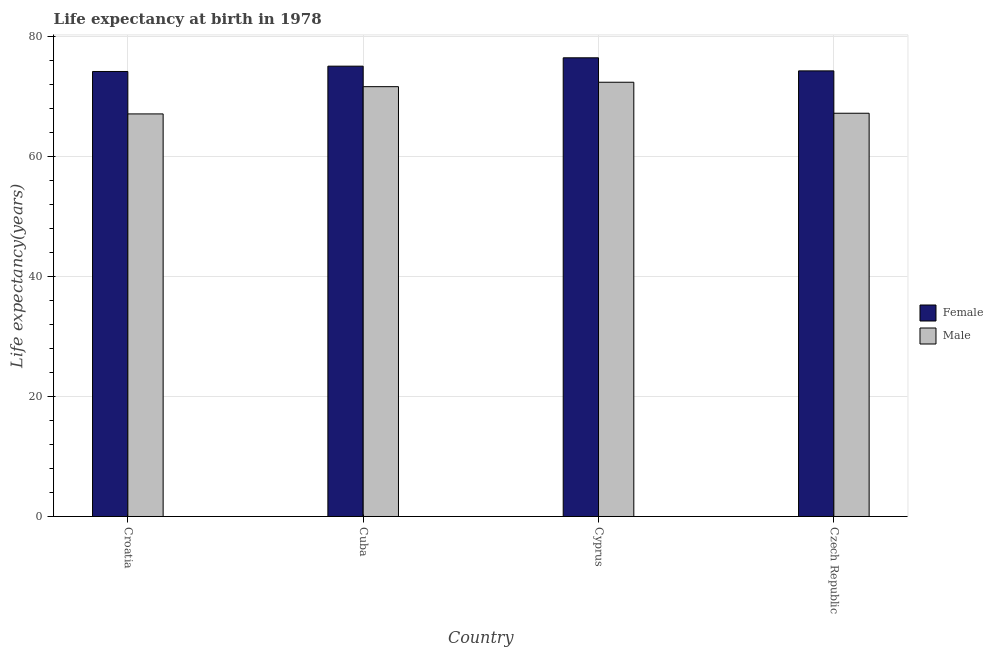Are the number of bars on each tick of the X-axis equal?
Offer a terse response. Yes. How many bars are there on the 1st tick from the left?
Your answer should be very brief. 2. How many bars are there on the 4th tick from the right?
Your answer should be compact. 2. What is the label of the 1st group of bars from the left?
Provide a short and direct response. Croatia. What is the life expectancy(male) in Croatia?
Your response must be concise. 67.09. Across all countries, what is the maximum life expectancy(male)?
Give a very brief answer. 72.37. Across all countries, what is the minimum life expectancy(male)?
Ensure brevity in your answer.  67.09. In which country was the life expectancy(female) maximum?
Keep it short and to the point. Cyprus. In which country was the life expectancy(male) minimum?
Provide a short and direct response. Croatia. What is the total life expectancy(female) in the graph?
Your response must be concise. 299.91. What is the difference between the life expectancy(female) in Croatia and that in Cuba?
Your response must be concise. -0.89. What is the difference between the life expectancy(female) in Croatia and the life expectancy(male) in Czech Republic?
Your answer should be very brief. 6.96. What is the average life expectancy(female) per country?
Your answer should be very brief. 74.98. What is the difference between the life expectancy(female) and life expectancy(male) in Cyprus?
Your answer should be compact. 4.07. What is the ratio of the life expectancy(female) in Cyprus to that in Czech Republic?
Your response must be concise. 1.03. Is the life expectancy(male) in Croatia less than that in Czech Republic?
Keep it short and to the point. Yes. Is the difference between the life expectancy(female) in Croatia and Cuba greater than the difference between the life expectancy(male) in Croatia and Cuba?
Provide a short and direct response. Yes. What is the difference between the highest and the second highest life expectancy(female)?
Make the answer very short. 1.39. What is the difference between the highest and the lowest life expectancy(female)?
Your response must be concise. 2.28. In how many countries, is the life expectancy(female) greater than the average life expectancy(female) taken over all countries?
Give a very brief answer. 2. What does the 2nd bar from the left in Cuba represents?
Make the answer very short. Male. How many countries are there in the graph?
Ensure brevity in your answer.  4. What is the difference between two consecutive major ticks on the Y-axis?
Offer a terse response. 20. Are the values on the major ticks of Y-axis written in scientific E-notation?
Your answer should be very brief. No. Does the graph contain any zero values?
Your answer should be compact. No. Where does the legend appear in the graph?
Provide a succinct answer. Center right. What is the title of the graph?
Provide a succinct answer. Life expectancy at birth in 1978. What is the label or title of the Y-axis?
Give a very brief answer. Life expectancy(years). What is the Life expectancy(years) of Female in Croatia?
Your answer should be compact. 74.16. What is the Life expectancy(years) of Male in Croatia?
Provide a succinct answer. 67.09. What is the Life expectancy(years) of Female in Cuba?
Provide a short and direct response. 75.05. What is the Life expectancy(years) in Male in Cuba?
Ensure brevity in your answer.  71.63. What is the Life expectancy(years) in Female in Cyprus?
Provide a succinct answer. 76.44. What is the Life expectancy(years) in Male in Cyprus?
Keep it short and to the point. 72.37. What is the Life expectancy(years) of Female in Czech Republic?
Give a very brief answer. 74.26. What is the Life expectancy(years) of Male in Czech Republic?
Your response must be concise. 67.2. Across all countries, what is the maximum Life expectancy(years) of Female?
Make the answer very short. 76.44. Across all countries, what is the maximum Life expectancy(years) of Male?
Your response must be concise. 72.37. Across all countries, what is the minimum Life expectancy(years) in Female?
Ensure brevity in your answer.  74.16. Across all countries, what is the minimum Life expectancy(years) of Male?
Keep it short and to the point. 67.09. What is the total Life expectancy(years) of Female in the graph?
Your answer should be compact. 299.9. What is the total Life expectancy(years) in Male in the graph?
Keep it short and to the point. 278.29. What is the difference between the Life expectancy(years) of Female in Croatia and that in Cuba?
Keep it short and to the point. -0.89. What is the difference between the Life expectancy(years) in Male in Croatia and that in Cuba?
Offer a very short reply. -4.54. What is the difference between the Life expectancy(years) in Female in Croatia and that in Cyprus?
Keep it short and to the point. -2.28. What is the difference between the Life expectancy(years) in Male in Croatia and that in Cyprus?
Ensure brevity in your answer.  -5.28. What is the difference between the Life expectancy(years) of Female in Croatia and that in Czech Republic?
Your answer should be compact. -0.1. What is the difference between the Life expectancy(years) in Male in Croatia and that in Czech Republic?
Make the answer very short. -0.11. What is the difference between the Life expectancy(years) in Female in Cuba and that in Cyprus?
Offer a very short reply. -1.39. What is the difference between the Life expectancy(years) of Male in Cuba and that in Cyprus?
Your answer should be compact. -0.74. What is the difference between the Life expectancy(years) in Female in Cuba and that in Czech Republic?
Give a very brief answer. 0.79. What is the difference between the Life expectancy(years) of Male in Cuba and that in Czech Republic?
Provide a short and direct response. 4.43. What is the difference between the Life expectancy(years) in Female in Cyprus and that in Czech Republic?
Your answer should be compact. 2.18. What is the difference between the Life expectancy(years) of Male in Cyprus and that in Czech Republic?
Your response must be concise. 5.17. What is the difference between the Life expectancy(years) of Female in Croatia and the Life expectancy(years) of Male in Cuba?
Your answer should be very brief. 2.53. What is the difference between the Life expectancy(years) of Female in Croatia and the Life expectancy(years) of Male in Cyprus?
Your answer should be very brief. 1.79. What is the difference between the Life expectancy(years) of Female in Croatia and the Life expectancy(years) of Male in Czech Republic?
Give a very brief answer. 6.96. What is the difference between the Life expectancy(years) in Female in Cuba and the Life expectancy(years) in Male in Cyprus?
Your answer should be very brief. 2.68. What is the difference between the Life expectancy(years) in Female in Cuba and the Life expectancy(years) in Male in Czech Republic?
Keep it short and to the point. 7.85. What is the difference between the Life expectancy(years) of Female in Cyprus and the Life expectancy(years) of Male in Czech Republic?
Your answer should be very brief. 9.24. What is the average Life expectancy(years) of Female per country?
Give a very brief answer. 74.98. What is the average Life expectancy(years) in Male per country?
Give a very brief answer. 69.57. What is the difference between the Life expectancy(years) in Female and Life expectancy(years) in Male in Croatia?
Provide a succinct answer. 7.07. What is the difference between the Life expectancy(years) of Female and Life expectancy(years) of Male in Cuba?
Offer a very short reply. 3.42. What is the difference between the Life expectancy(years) in Female and Life expectancy(years) in Male in Cyprus?
Your response must be concise. 4.07. What is the difference between the Life expectancy(years) in Female and Life expectancy(years) in Male in Czech Republic?
Your answer should be very brief. 7.06. What is the ratio of the Life expectancy(years) in Male in Croatia to that in Cuba?
Offer a terse response. 0.94. What is the ratio of the Life expectancy(years) in Female in Croatia to that in Cyprus?
Provide a succinct answer. 0.97. What is the ratio of the Life expectancy(years) in Male in Croatia to that in Cyprus?
Keep it short and to the point. 0.93. What is the ratio of the Life expectancy(years) of Female in Croatia to that in Czech Republic?
Make the answer very short. 1. What is the ratio of the Life expectancy(years) of Male in Croatia to that in Czech Republic?
Keep it short and to the point. 1. What is the ratio of the Life expectancy(years) of Female in Cuba to that in Cyprus?
Offer a terse response. 0.98. What is the ratio of the Life expectancy(years) in Male in Cuba to that in Cyprus?
Your answer should be very brief. 0.99. What is the ratio of the Life expectancy(years) of Female in Cuba to that in Czech Republic?
Give a very brief answer. 1.01. What is the ratio of the Life expectancy(years) in Male in Cuba to that in Czech Republic?
Make the answer very short. 1.07. What is the ratio of the Life expectancy(years) in Female in Cyprus to that in Czech Republic?
Your answer should be very brief. 1.03. What is the difference between the highest and the second highest Life expectancy(years) in Female?
Provide a succinct answer. 1.39. What is the difference between the highest and the second highest Life expectancy(years) in Male?
Your response must be concise. 0.74. What is the difference between the highest and the lowest Life expectancy(years) in Female?
Offer a very short reply. 2.28. What is the difference between the highest and the lowest Life expectancy(years) in Male?
Ensure brevity in your answer.  5.28. 